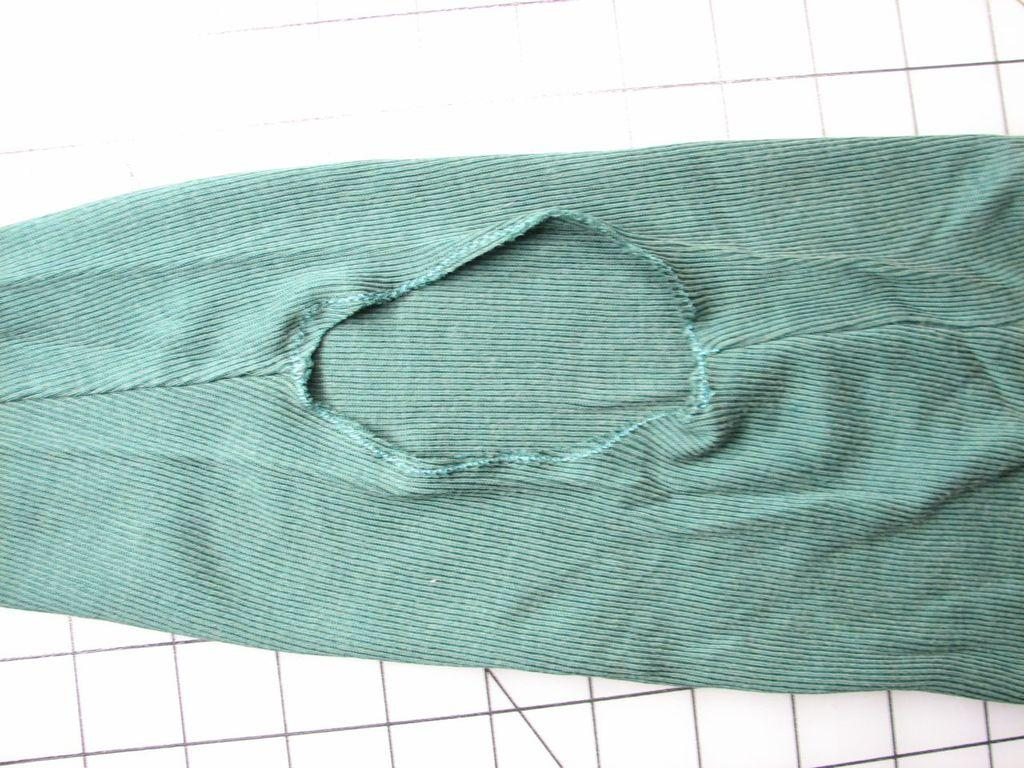What color is the cloth in the image? The cloth in the image is blue. What colors are present on the floor in the image? The floor in the image is white and black in color. How many weeks can be seen in the image? There is no reference to weeks in the image, so it is not possible to determine how many weeks might be present. 